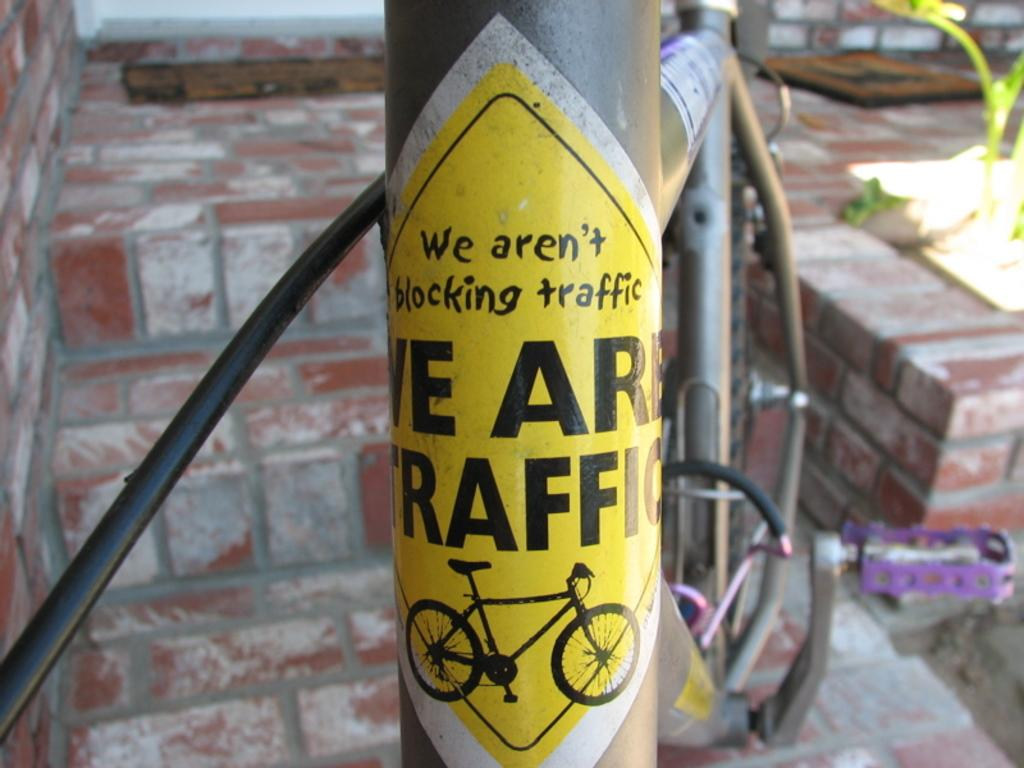What is attached to the pole in the image? There is a sticker attached to the pole in the image. What can be seen in the background of the image? There is a plant, rods, and a brick wall visible in the background of the image. How many women are playing in the field in the image? There is no field or women present in the image. What type of paint is being used on the plant in the image? There is no paint or indication of paint use on the plant in the image. 